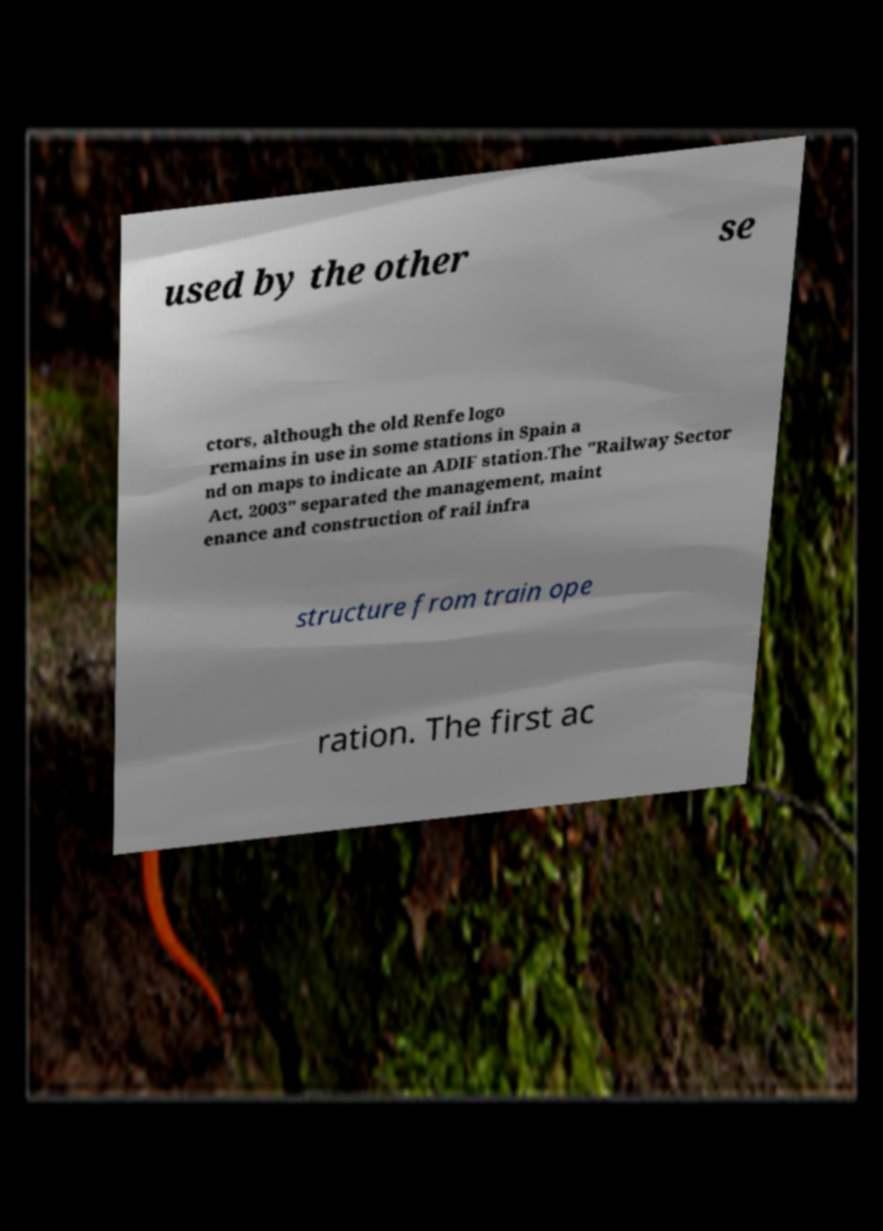What messages or text are displayed in this image? I need them in a readable, typed format. used by the other se ctors, although the old Renfe logo remains in use in some stations in Spain a nd on maps to indicate an ADIF station.The "Railway Sector Act, 2003" separated the management, maint enance and construction of rail infra structure from train ope ration. The first ac 